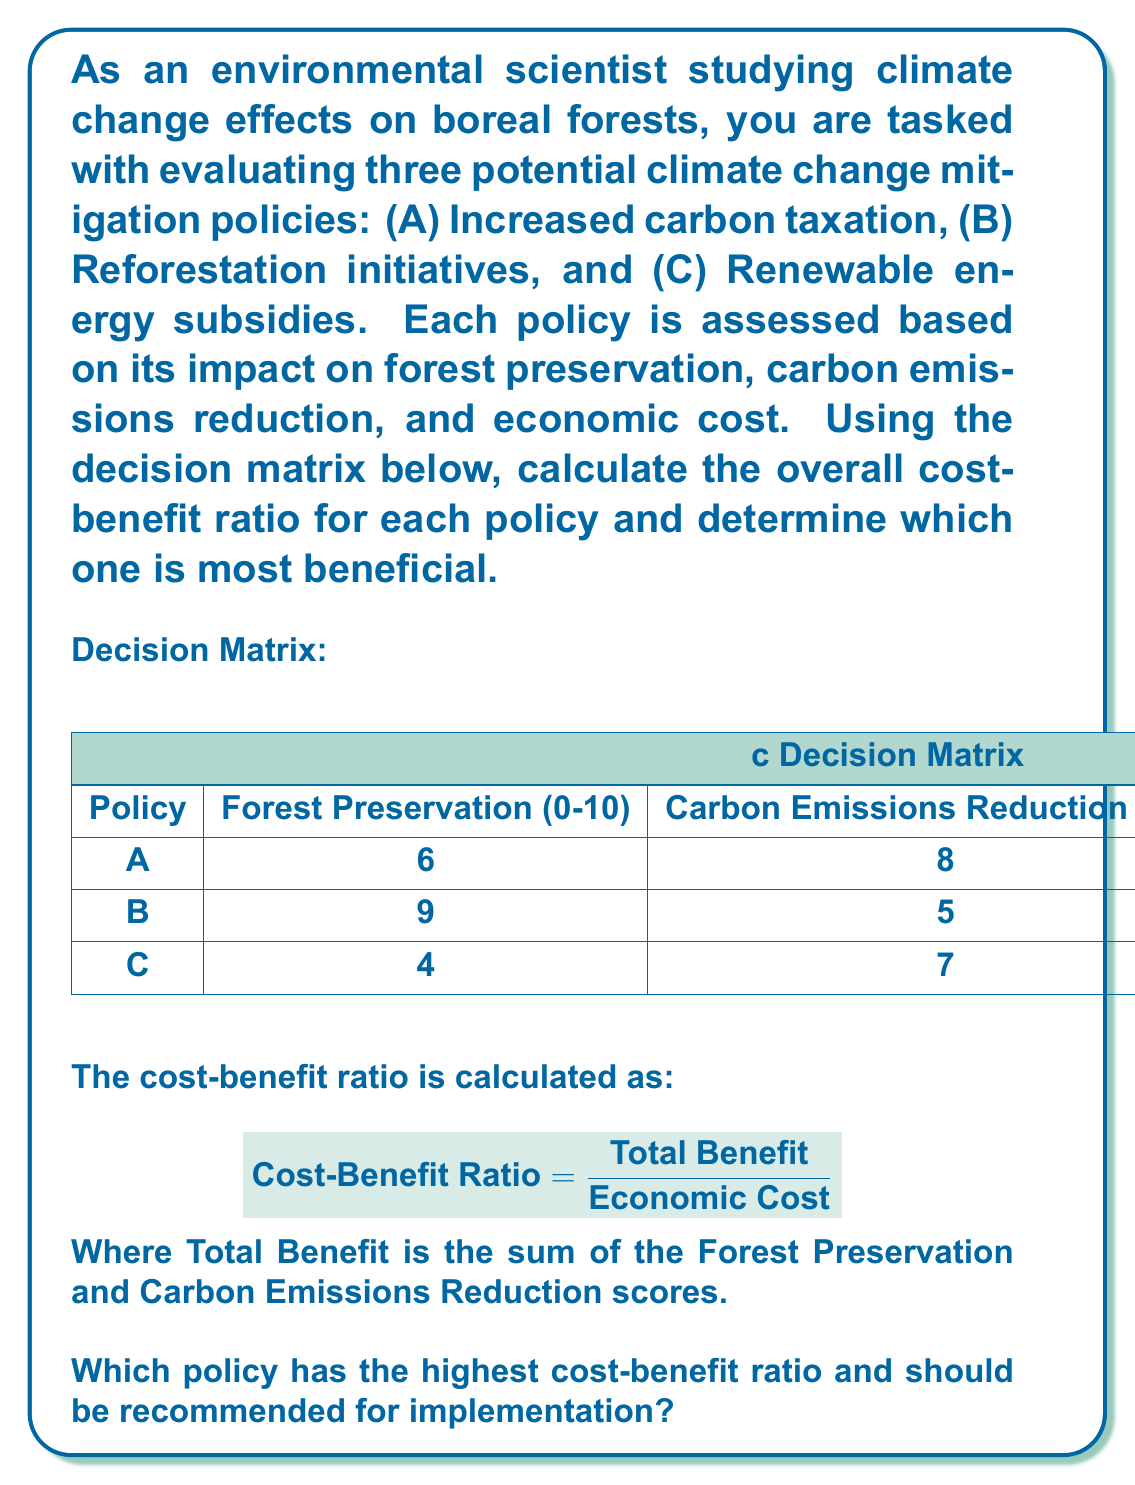Can you answer this question? To solve this problem, we need to calculate the cost-benefit ratio for each policy using the given formula. Let's go through the process step-by-step:

1. Calculate the Total Benefit for each policy:
   Policy A: $6 + 8 = 14$
   Policy B: $9 + 5 = 14$
   Policy C: $4 + 7 = 11$

2. Calculate the Cost-Benefit Ratio for each policy:

   Policy A:
   $$ \text{Cost-Benefit Ratio}_A = \frac{14}{50} = 0.28 $$

   Policy B:
   $$ \text{Cost-Benefit Ratio}_B = \frac{14}{30} \approx 0.47 $$

   Policy C:
   $$ \text{Cost-Benefit Ratio}_C = \frac{11}{40} = 0.275 $$

3. Compare the cost-benefit ratios:
   Policy A: 0.28
   Policy B: 0.47
   Policy C: 0.275

Policy B has the highest cost-benefit ratio at 0.47, which means it provides the most benefit per unit of economic cost.
Answer: Policy B (Reforestation initiatives) has the highest cost-benefit ratio of 0.47 and should be recommended for implementation. 